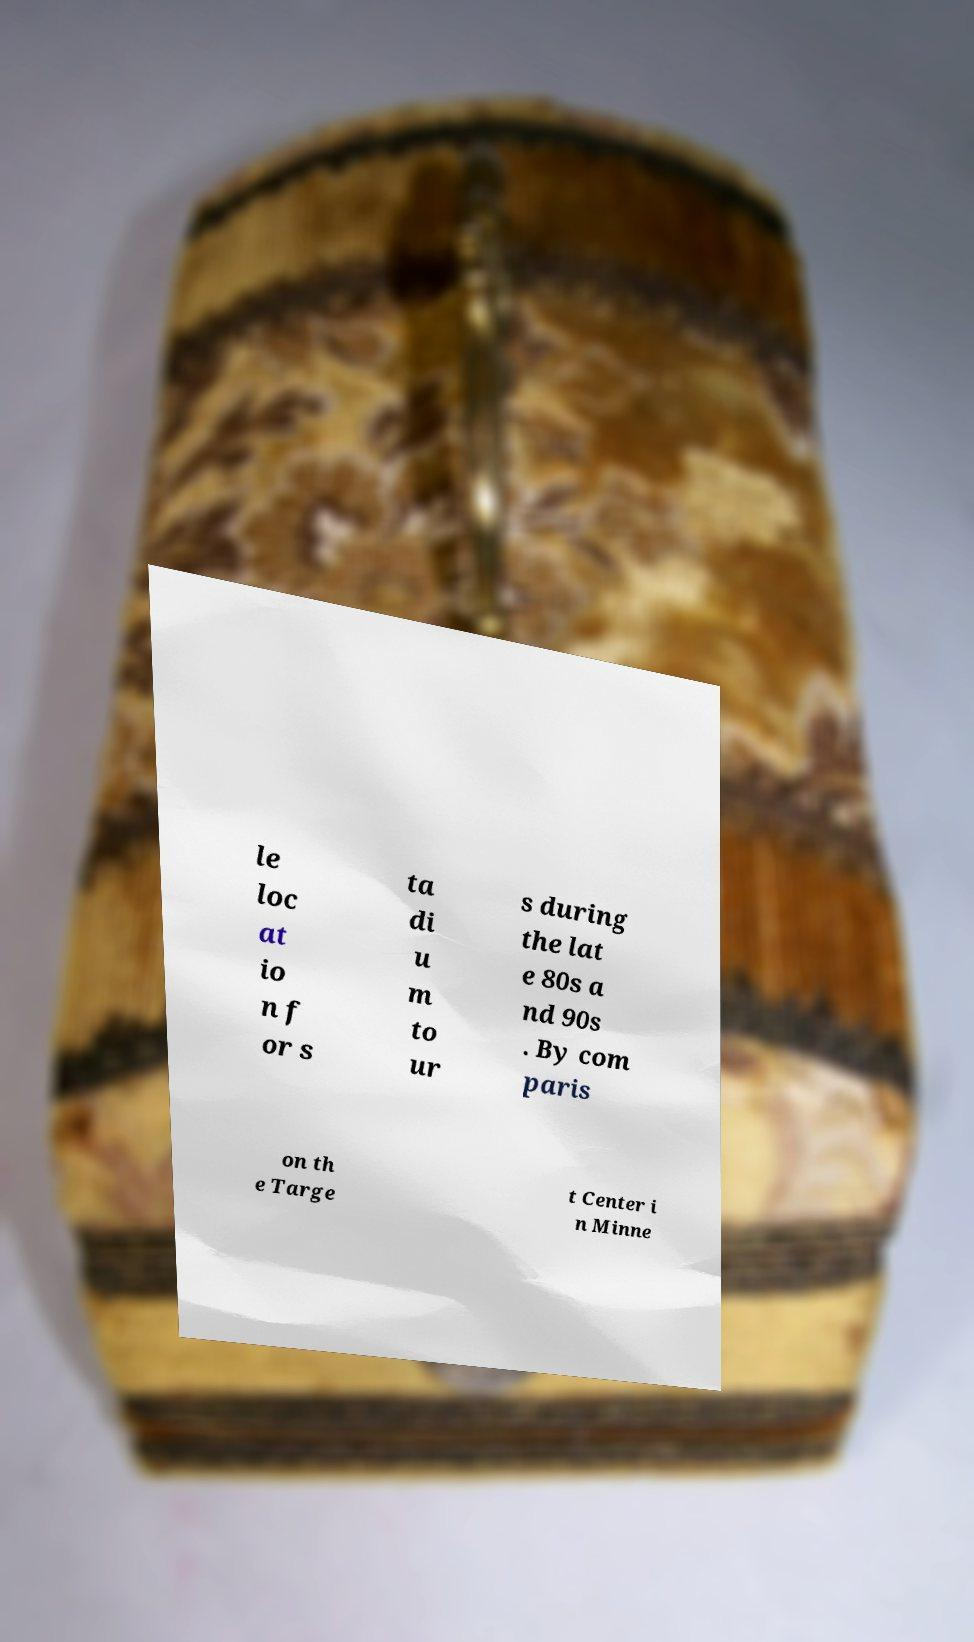For documentation purposes, I need the text within this image transcribed. Could you provide that? le loc at io n f or s ta di u m to ur s during the lat e 80s a nd 90s . By com paris on th e Targe t Center i n Minne 